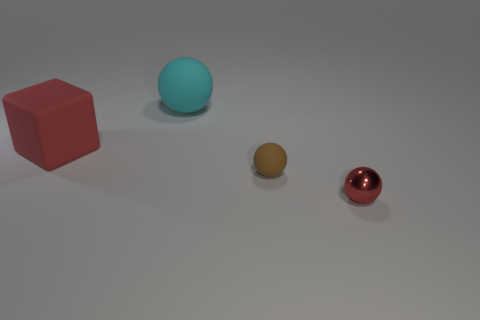Add 2 red matte blocks. How many objects exist? 6 Subtract all rubber balls. How many balls are left? 1 Subtract 1 balls. How many balls are left? 2 Subtract all red balls. How many balls are left? 2 Subtract all spheres. How many objects are left? 1 Subtract all yellow balls. Subtract all gray cylinders. How many balls are left? 3 Subtract all cyan blocks. How many cyan balls are left? 1 Subtract all small brown cubes. Subtract all brown matte balls. How many objects are left? 3 Add 1 red metal objects. How many red metal objects are left? 2 Add 3 tiny brown rubber things. How many tiny brown rubber things exist? 4 